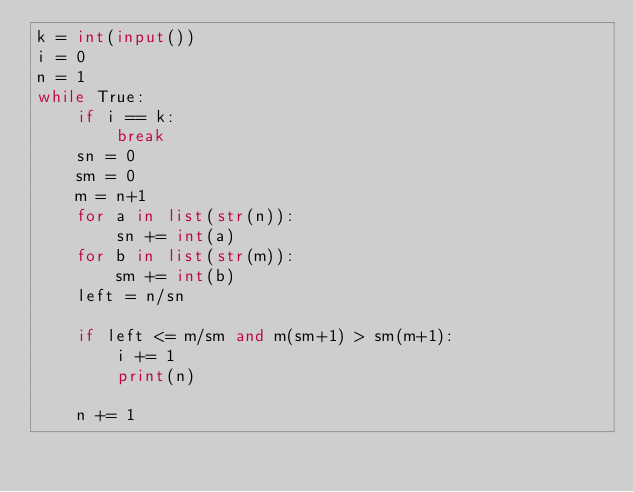<code> <loc_0><loc_0><loc_500><loc_500><_Python_>k = int(input())
i = 0
n = 1
while True:
    if i == k:
        break
    sn = 0
    sm = 0
    m = n+1
    for a in list(str(n)):
        sn += int(a)
    for b in list(str(m)):
        sm += int(b)
    left = n/sn
    
    if left <= m/sm and m(sm+1) > sm(m+1):
        i += 1
        print(n)
    
    n += 1
    

</code> 